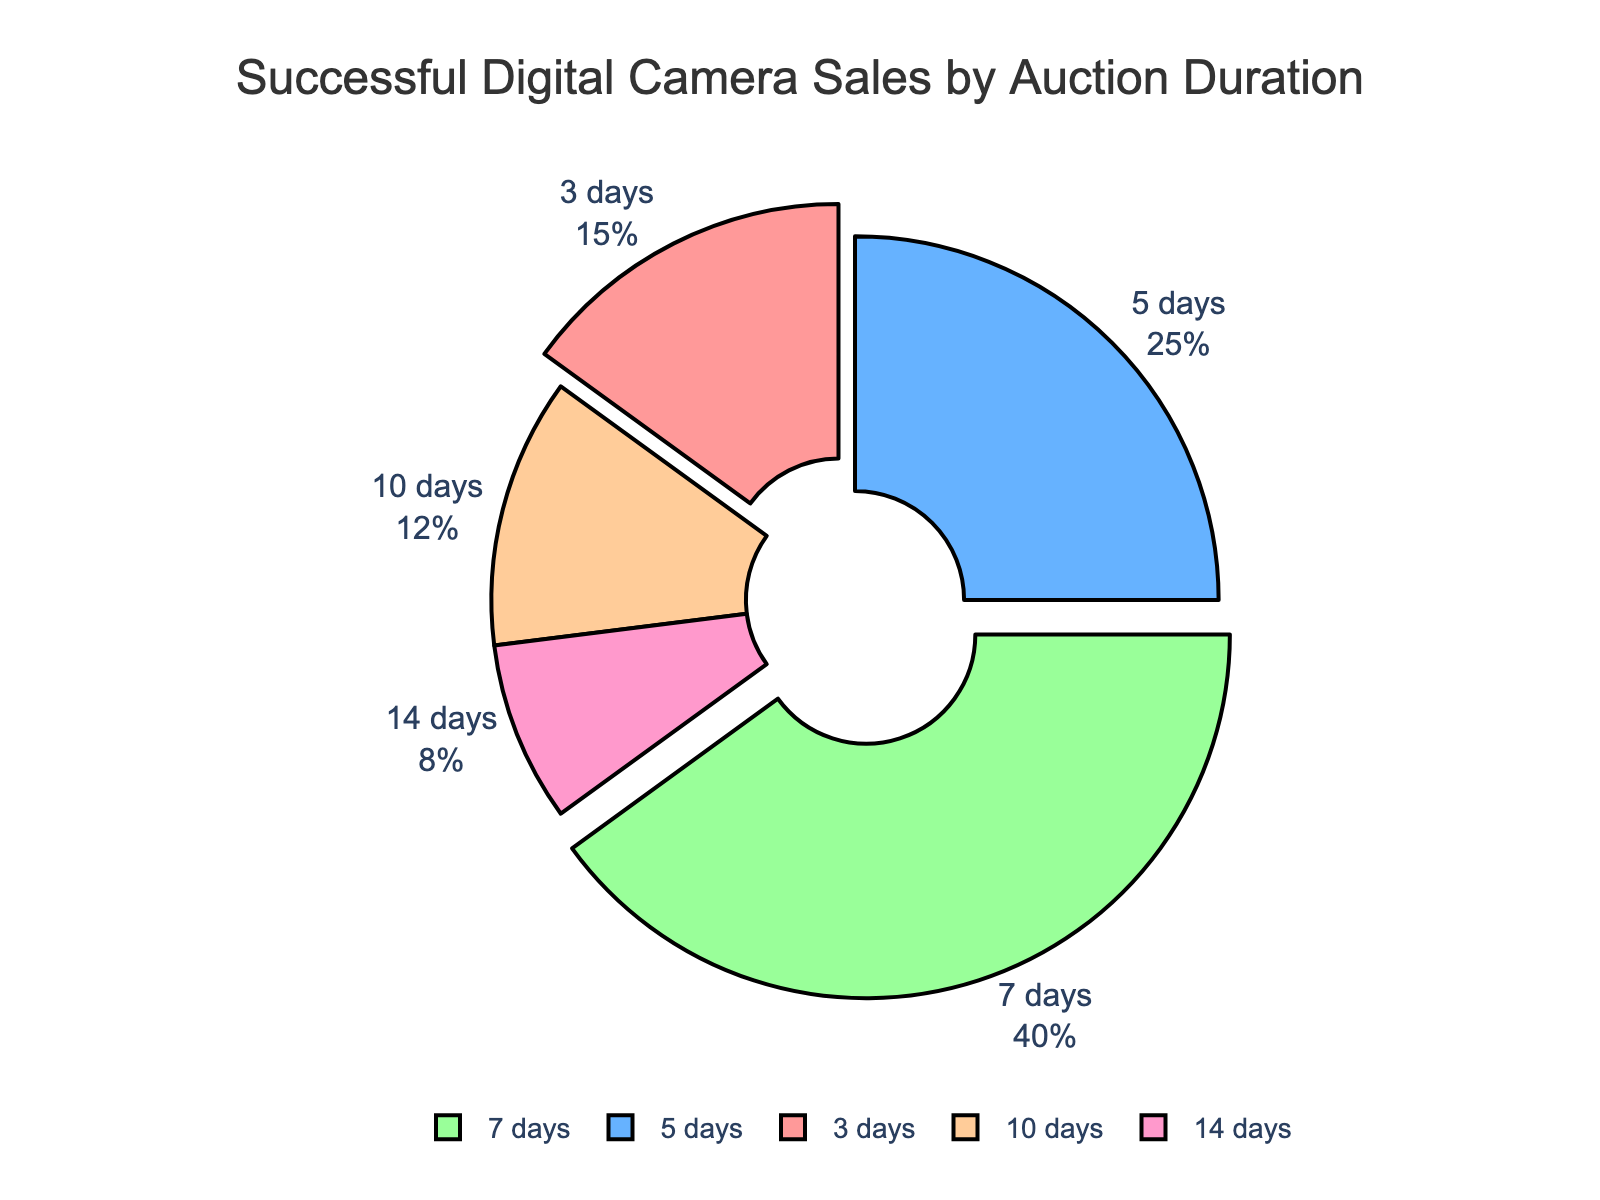Which auction duration has the highest percentage of successful sales? The segment with the highest percentage is represented by the largest slice of the pie chart. The slice labeled "7 days" is the largest.
Answer: 7 days How much higher is the percentage of successful sales for 5-day auctions compared to 10-day auctions? Identify the percentages for both durations: 5 days (25%) and 10 days (12%). Subtract the smaller percentage from the larger one: 25% - 12% = 13%.
Answer: 13% What is the combined percentage of successful sales for auctions lasting either 3 days or 14 days? Find the percentages for both durations: 3 days (15%) and 14 days (8%). Add them together: 15% + 8% = 23%.
Answer: 23% Which auction duration corresponds to the slice colored blue? The blue slice corresponds to the 5 days label, which is visible on the chart.
Answer: 5 days Arrange the auction durations in ascending order of their successful sales percentages. Inspect the percentages labeled: 14 days (8%), 10 days (12%), 3 days (15%), 5 days (25%), and 7 days (40%).
Answer: 14 days, 10 days, 3 days, 5 days, 7 days If you add the percentages of the 3-day, 10-day, and 14-day auctions, what would be the result? Locate the percentages for these durations: 3 days (15%), 10 days (12%), and 14 days (8%). Add them: 15% + 12% + 8% = 35%.
Answer: 35% Which auction durations have pulled-out (separated) slices in the pie chart? By looking at the chart, the pulled-out slices are labeled as 3 days and 7 days.
Answer: 3 days, 7 days 